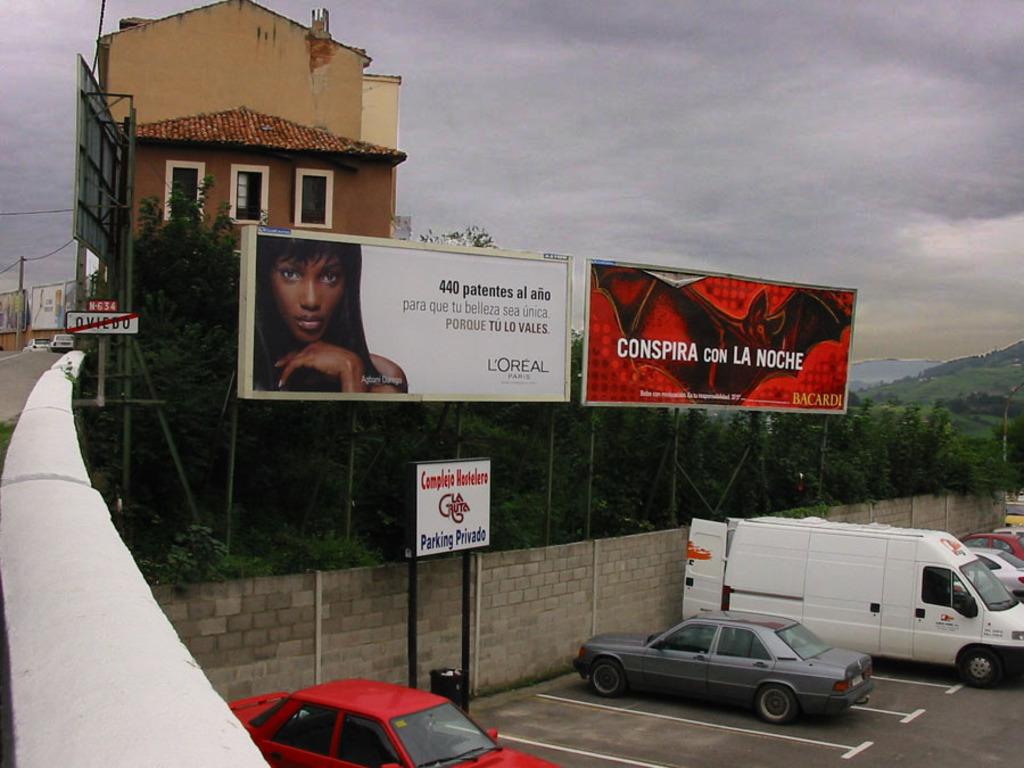Where is is the loreal company headquartered?
Make the answer very short. Paris. 